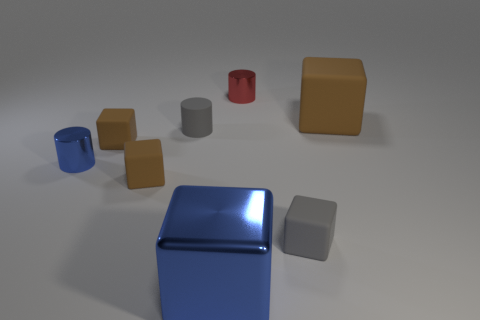What is the shape of the tiny matte object that is the same color as the small rubber cylinder?
Ensure brevity in your answer.  Cube. What number of gray cylinders have the same material as the tiny gray cube?
Ensure brevity in your answer.  1. The large matte block is what color?
Ensure brevity in your answer.  Brown. What is the color of the matte cylinder that is the same size as the gray matte cube?
Your answer should be very brief. Gray. Is there a matte cube of the same color as the matte cylinder?
Your answer should be very brief. Yes. Is the shape of the gray matte thing to the left of the red cylinder the same as the brown thing right of the red metal object?
Your answer should be compact. No. There is a metallic cylinder that is the same color as the large metal thing; what size is it?
Provide a short and direct response. Small. What number of other objects are the same size as the gray rubber cylinder?
Your answer should be very brief. 5. Do the metallic block and the small shiny object that is behind the big brown cube have the same color?
Provide a succinct answer. No. Is the number of tiny brown matte things that are to the right of the big brown matte thing less than the number of brown matte cubes behind the matte cylinder?
Make the answer very short. Yes. 